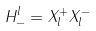<formula> <loc_0><loc_0><loc_500><loc_500>H ^ { l } _ { - } = X ^ { + } _ { l } X ^ { - } _ { l }</formula> 